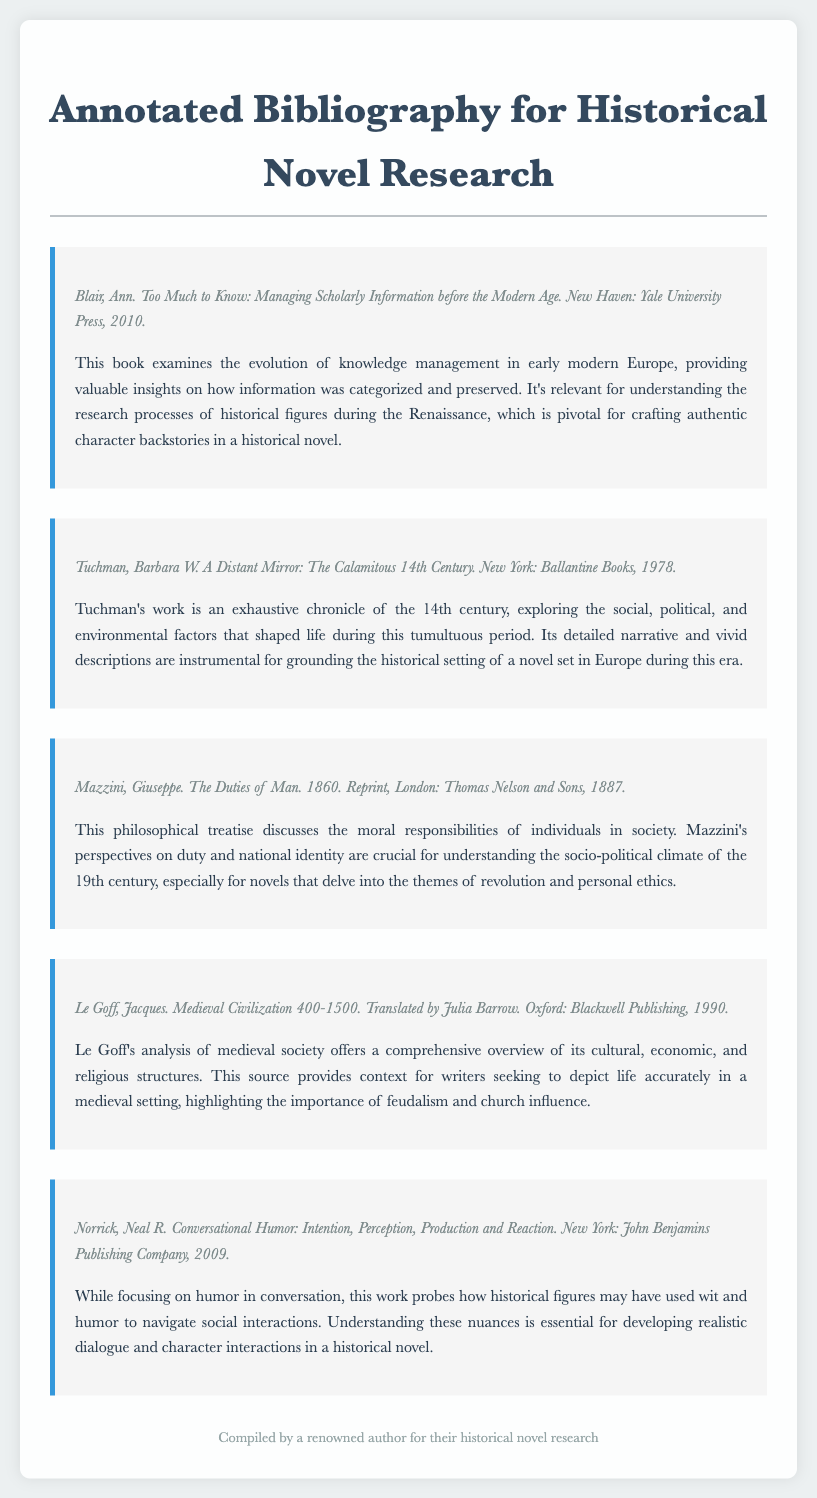What is the title of the first source? The title of the first source is provided in the citation section of the document, which is "Too Much to Know: Managing Scholarly Information before the Modern Age."
Answer: Too Much to Know: Managing Scholarly Information before the Modern Age Who authored "A Distant Mirror: The Calamitous 14th Century"? The author of this work is mentioned in the citation of the source, which is Barbara W. Tuchman.
Answer: Barbara W. Tuchman What year was "The Duties of Man" originally published? The original publication year is noted in the entry, which states it was published in 1860.
Answer: 1860 What is the main theme of Mazzini's work? The summary of Mazzini’s work highlights the discussion of moral responsibilities and national identity, which points towards the theme of duty and ethics.
Answer: Duty and ethics Which publisher released "Medieval Civilization 400-1500"? The publishing information is provided in the citation section for the source, which states it was published by Blackwell Publishing.
Answer: Blackwell Publishing How many sources are listed in the annotated bibliography? The document lists all the sources included, which can be counted to find the total number, totaling five sources.
Answer: Five sources What is the significance of Le Goff's analysis for novelists? The relevance of Le Goff’s analysis is mentioned in the summary, which indicates it provides context for accurately depicting life in a medieval setting.
Answer: Accurately depicting life in a medieval setting Which author compiled the annotated bibliography? The footer of the document indicates who compiled this bibliography, stating it was compiled by a renowned author.
Answer: A renowned author 